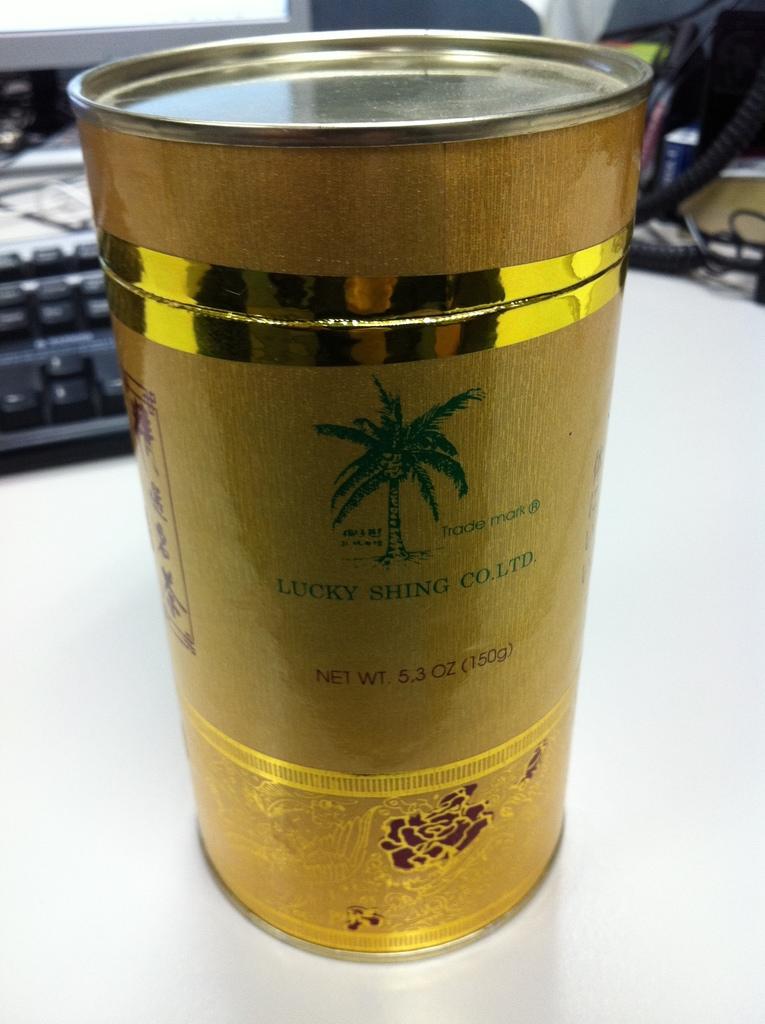What is the name of the company on the cup?
Provide a succinct answer. Lucky shing co. ltd. 